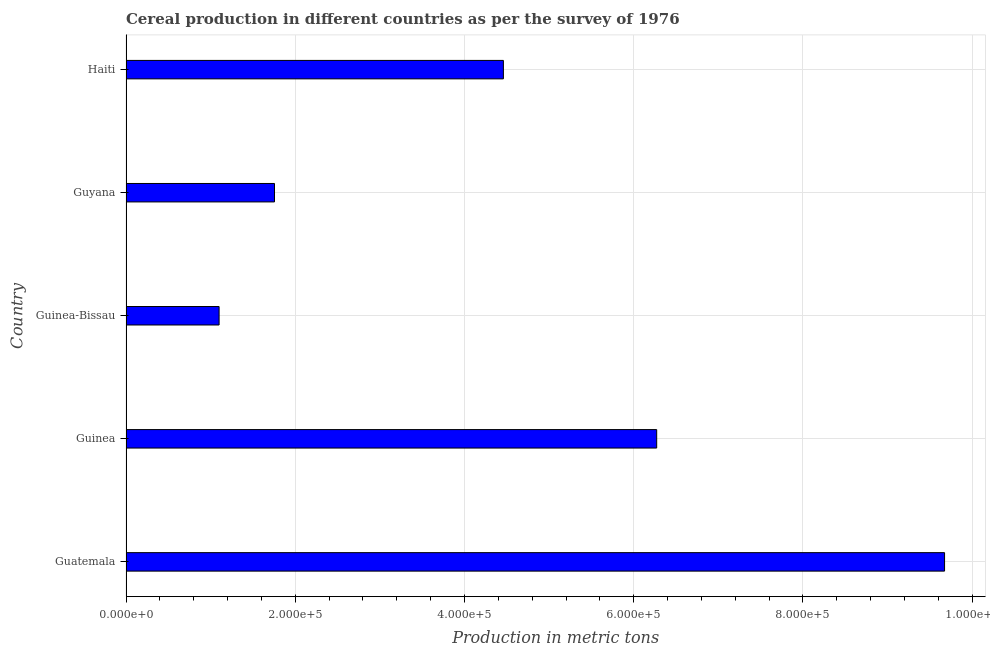Does the graph contain any zero values?
Give a very brief answer. No. Does the graph contain grids?
Keep it short and to the point. Yes. What is the title of the graph?
Your answer should be compact. Cereal production in different countries as per the survey of 1976. What is the label or title of the X-axis?
Offer a terse response. Production in metric tons. What is the label or title of the Y-axis?
Offer a terse response. Country. Across all countries, what is the maximum cereal production?
Provide a short and direct response. 9.67e+05. Across all countries, what is the minimum cereal production?
Give a very brief answer. 1.10e+05. In which country was the cereal production maximum?
Make the answer very short. Guatemala. In which country was the cereal production minimum?
Make the answer very short. Guinea-Bissau. What is the sum of the cereal production?
Offer a terse response. 2.33e+06. What is the difference between the cereal production in Guinea and Guyana?
Your response must be concise. 4.52e+05. What is the average cereal production per country?
Offer a very short reply. 4.65e+05. What is the median cereal production?
Provide a short and direct response. 4.46e+05. In how many countries, is the cereal production greater than 920000 metric tons?
Offer a very short reply. 1. What is the ratio of the cereal production in Guatemala to that in Guinea-Bissau?
Your answer should be compact. 8.79. Is the difference between the cereal production in Guyana and Haiti greater than the difference between any two countries?
Your answer should be very brief. No. What is the difference between the highest and the second highest cereal production?
Give a very brief answer. 3.40e+05. Is the sum of the cereal production in Guatemala and Guyana greater than the maximum cereal production across all countries?
Your answer should be very brief. Yes. What is the difference between the highest and the lowest cereal production?
Give a very brief answer. 8.57e+05. In how many countries, is the cereal production greater than the average cereal production taken over all countries?
Provide a succinct answer. 2. How many bars are there?
Your answer should be very brief. 5. Are the values on the major ticks of X-axis written in scientific E-notation?
Keep it short and to the point. Yes. What is the Production in metric tons of Guatemala?
Provide a short and direct response. 9.67e+05. What is the Production in metric tons of Guinea?
Provide a short and direct response. 6.27e+05. What is the Production in metric tons in Guinea-Bissau?
Keep it short and to the point. 1.10e+05. What is the Production in metric tons in Guyana?
Give a very brief answer. 1.75e+05. What is the Production in metric tons of Haiti?
Your answer should be compact. 4.46e+05. What is the difference between the Production in metric tons in Guatemala and Guinea?
Offer a very short reply. 3.40e+05. What is the difference between the Production in metric tons in Guatemala and Guinea-Bissau?
Give a very brief answer. 8.57e+05. What is the difference between the Production in metric tons in Guatemala and Guyana?
Ensure brevity in your answer.  7.92e+05. What is the difference between the Production in metric tons in Guatemala and Haiti?
Provide a succinct answer. 5.21e+05. What is the difference between the Production in metric tons in Guinea and Guinea-Bissau?
Your answer should be compact. 5.17e+05. What is the difference between the Production in metric tons in Guinea and Guyana?
Your answer should be compact. 4.52e+05. What is the difference between the Production in metric tons in Guinea and Haiti?
Offer a very short reply. 1.81e+05. What is the difference between the Production in metric tons in Guinea-Bissau and Guyana?
Give a very brief answer. -6.55e+04. What is the difference between the Production in metric tons in Guinea-Bissau and Haiti?
Provide a short and direct response. -3.36e+05. What is the difference between the Production in metric tons in Guyana and Haiti?
Ensure brevity in your answer.  -2.71e+05. What is the ratio of the Production in metric tons in Guatemala to that in Guinea?
Provide a succinct answer. 1.54. What is the ratio of the Production in metric tons in Guatemala to that in Guinea-Bissau?
Your answer should be very brief. 8.79. What is the ratio of the Production in metric tons in Guatemala to that in Guyana?
Offer a terse response. 5.51. What is the ratio of the Production in metric tons in Guatemala to that in Haiti?
Provide a succinct answer. 2.17. What is the ratio of the Production in metric tons in Guinea to that in Guinea-Bissau?
Offer a very short reply. 5.7. What is the ratio of the Production in metric tons in Guinea to that in Guyana?
Your answer should be compact. 3.57. What is the ratio of the Production in metric tons in Guinea to that in Haiti?
Give a very brief answer. 1.41. What is the ratio of the Production in metric tons in Guinea-Bissau to that in Guyana?
Your answer should be very brief. 0.63. What is the ratio of the Production in metric tons in Guinea-Bissau to that in Haiti?
Offer a very short reply. 0.25. What is the ratio of the Production in metric tons in Guyana to that in Haiti?
Make the answer very short. 0.39. 